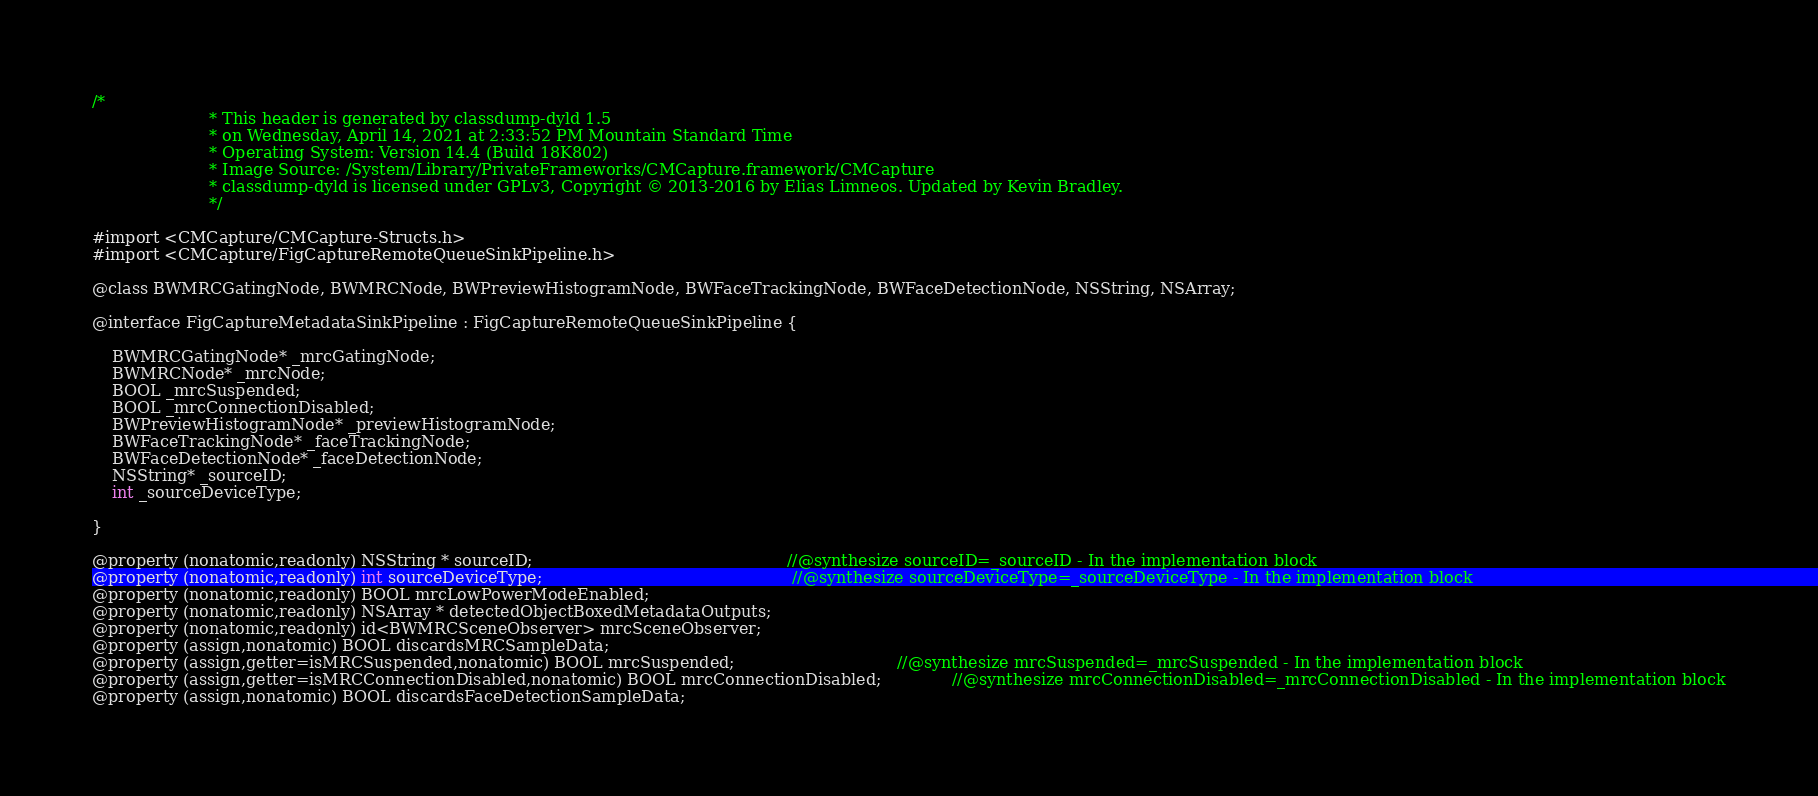<code> <loc_0><loc_0><loc_500><loc_500><_C_>/*
                       * This header is generated by classdump-dyld 1.5
                       * on Wednesday, April 14, 2021 at 2:33:52 PM Mountain Standard Time
                       * Operating System: Version 14.4 (Build 18K802)
                       * Image Source: /System/Library/PrivateFrameworks/CMCapture.framework/CMCapture
                       * classdump-dyld is licensed under GPLv3, Copyright © 2013-2016 by Elias Limneos. Updated by Kevin Bradley.
                       */

#import <CMCapture/CMCapture-Structs.h>
#import <CMCapture/FigCaptureRemoteQueueSinkPipeline.h>

@class BWMRCGatingNode, BWMRCNode, BWPreviewHistogramNode, BWFaceTrackingNode, BWFaceDetectionNode, NSString, NSArray;

@interface FigCaptureMetadataSinkPipeline : FigCaptureRemoteQueueSinkPipeline {

	BWMRCGatingNode* _mrcGatingNode;
	BWMRCNode* _mrcNode;
	BOOL _mrcSuspended;
	BOOL _mrcConnectionDisabled;
	BWPreviewHistogramNode* _previewHistogramNode;
	BWFaceTrackingNode* _faceTrackingNode;
	BWFaceDetectionNode* _faceDetectionNode;
	NSString* _sourceID;
	int _sourceDeviceType;

}

@property (nonatomic,readonly) NSString * sourceID;                                                  //@synthesize sourceID=_sourceID - In the implementation block
@property (nonatomic,readonly) int sourceDeviceType;                                                 //@synthesize sourceDeviceType=_sourceDeviceType - In the implementation block
@property (nonatomic,readonly) BOOL mrcLowPowerModeEnabled; 
@property (nonatomic,readonly) NSArray * detectedObjectBoxedMetadataOutputs; 
@property (nonatomic,readonly) id<BWMRCSceneObserver> mrcSceneObserver; 
@property (assign,nonatomic) BOOL discardsMRCSampleData; 
@property (assign,getter=isMRCSuspended,nonatomic) BOOL mrcSuspended;                                //@synthesize mrcSuspended=_mrcSuspended - In the implementation block
@property (assign,getter=isMRCConnectionDisabled,nonatomic) BOOL mrcConnectionDisabled;              //@synthesize mrcConnectionDisabled=_mrcConnectionDisabled - In the implementation block
@property (assign,nonatomic) BOOL discardsFaceDetectionSampleData; </code> 